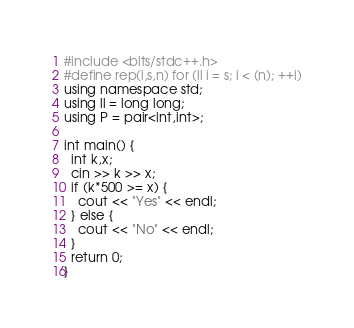Convert code to text. <code><loc_0><loc_0><loc_500><loc_500><_Python_>#include <bits/stdc++.h>
#define rep(i,s,n) for (ll i = s; i < (n); ++i)
using namespace std;
using ll = long long;
using P = pair<int,int>;

int main() {
  int k,x;
  cin >> k >> x;
  if (k*500 >= x) {
    cout << "Yes" << endl;
  } else {
    cout << "No" << endl;
  }
  return 0;
}
</code> 